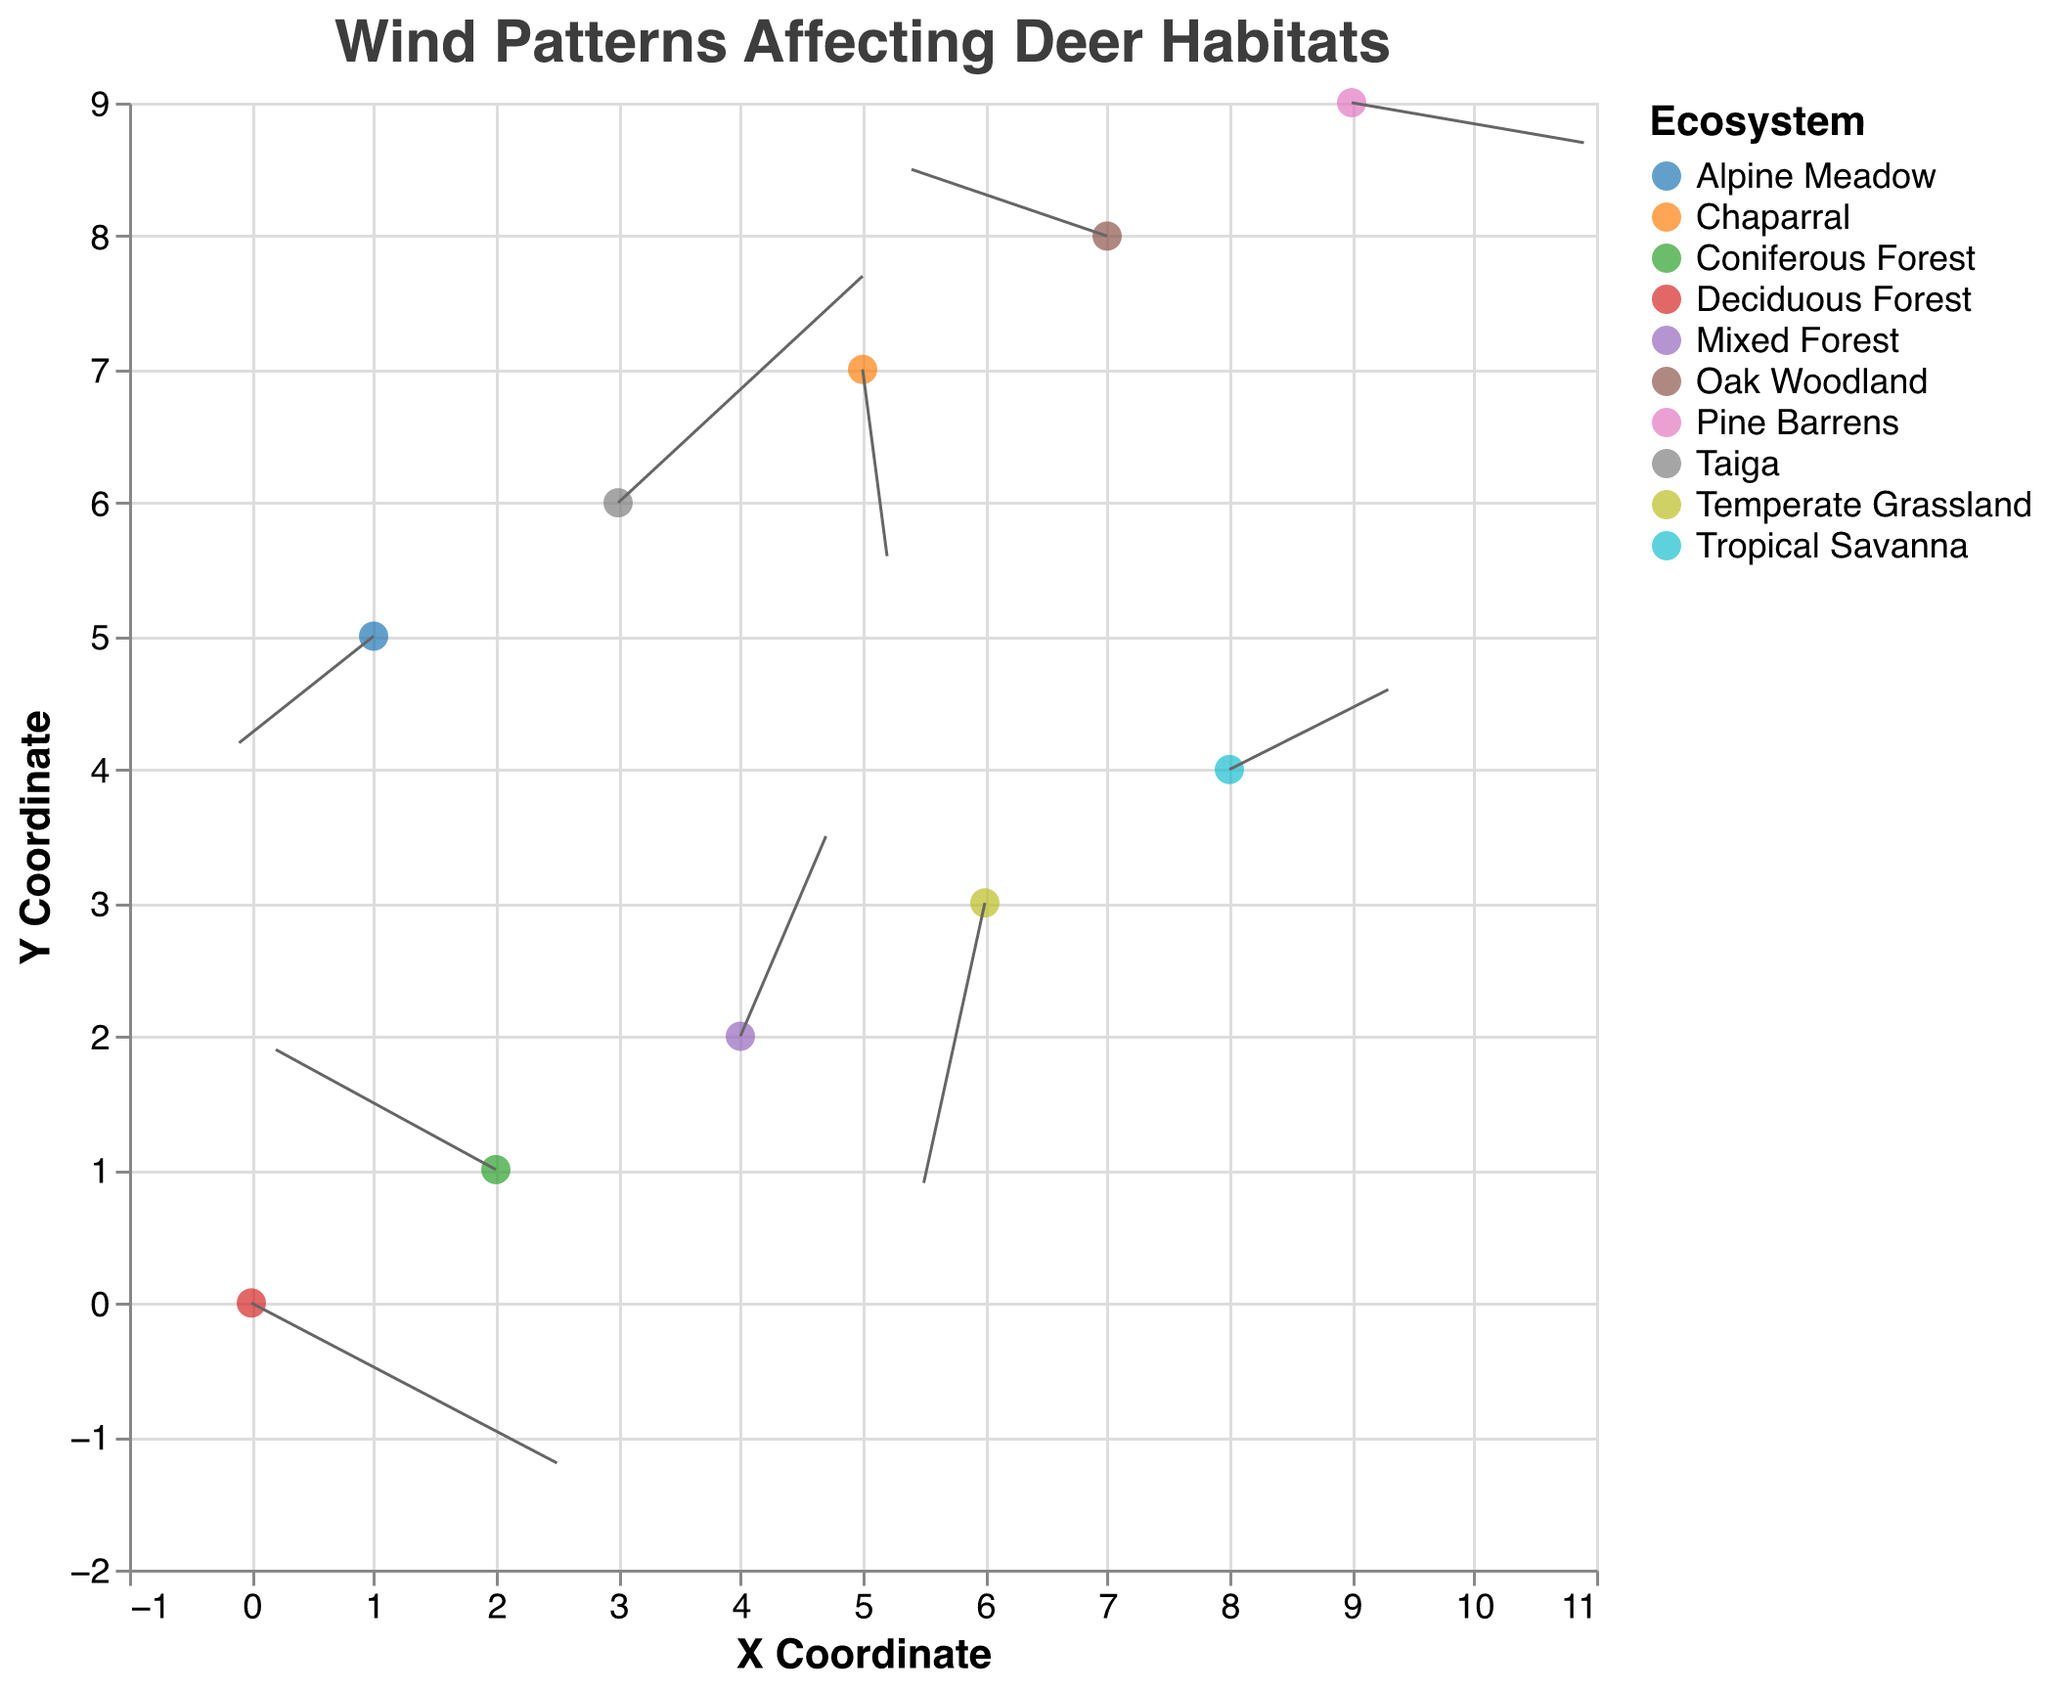How many different ecosystems are represented in the figure? Count each unique ecosystem name in the legend or color coding in the figure. The legend lists 10 different ecosystems.
Answer: 10 Which ecosystem has the wind vector with the largest magnitude in the positive x-direction? Look at the length of the arrows along the x-axis and identify the one with the largest positive x-component (u value). The Deciduous Forest has a u value of 2.5.
Answer: Deciduous Forest What is the color coding for the 'Alpine Meadow' ecosystem? Refer to the legend to find the color associated with the 'Alpine Meadow' ecosystem. The legend shows the color for 'Alpine Meadow' is represented in one of the 10 different schemes.
Answer: The specific color shown in the legend (e.g., purple) Which ecosystems have a negative y-component of wind? Look at the u and v values for each ecosystem and identify those with a negative v value. These are Deciduous Forest (v = -1.2), Temperate Grassland (v = -2.1), Alpine Meadow (v = -0.8), Chaparral (v = -1.4), and Pine Barrens (v = -0.3).
Answer: Deciduous Forest, Temperate Grassland, Alpine Meadow, Chaparral, Pine Barrens For the ecosystem 'Taiga', what are the x and y coordinates? Refer to the data point for 'Taiga' and note the x and y values. In the figure, 'Taiga' is at (3, 6).
Answer: (3, 6) Compare the magnitude of wind vectors between the 'Taiga' and 'Mixed Forest' ecosystems. Which one is larger? Calculate the magnitude of each vector using the formula √(u² + v²). For Taiga: √(2.0² + 1.7²) ≈ 2.6; for Mixed Forest: √(0.7² + 1.5²) ≈ 1.7. 'Taiga' has a larger magnitude.
Answer: Taiga How does the direction of the wind vector in the 'Coniferous Forest' ecosystem compare to the 'Oak Woodland' ecosystem? Compare the u and v components of each vector. Coniferous Forest (u=-1.8, v=0.9) has a vector pointing left and slightly up, whereas Oak Woodland (u=-1.6, v=0.5) points left and slightly up. Both have similar directions, but Coniferous Forest points more upwards.
Answer: Both left and up, but Coniferous Forest more upwards What does the title of the figure indicate about the subject of the plot? The title is "Wind Patterns Affecting Deer Habitats," which indicates that the figure examines how wind patterns vary across different deer habitats in various ecosystems.
Answer: Wind patterns in deer habitats Which ecosystem has the smallest wind vector in terms of magnitude? Calculate the magnitude for each vector and identify the smallest one using the formula √(u² + v²). Among all, Chaparral (u=0.2, v=-1.4) has the smallest at √(0.2² + (-1.4)²) ≈ 1.42.
Answer: Chaparral If a wind vector points downwards in the 'Temperate Grassland,' what are the implications for deer living in this ecosystem? A downward wind vector suggests strong wind blowing southwards, which could affect the movement, migration, or distribution of deer in this habitat.
Answer: Strong southward winds affecting deer movement 